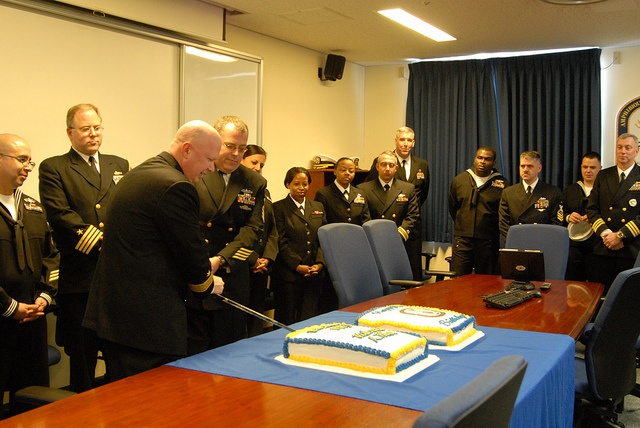Describe the objects in this image and their specific colors. I can see people in olive, black, brown, and maroon tones, dining table in olive, brown, red, and maroon tones, people in olive, black, and maroon tones, people in olive, black, maroon, brown, and orange tones, and people in olive, black, maroon, and brown tones in this image. 